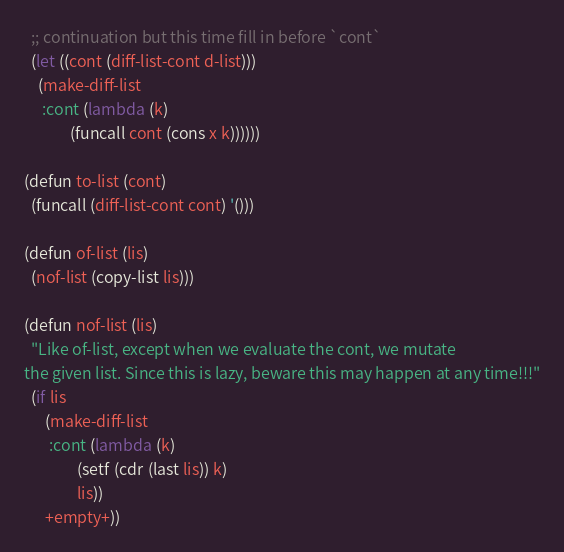Convert code to text. <code><loc_0><loc_0><loc_500><loc_500><_Lisp_>  ;; continuation but this time fill in before `cont`
  (let ((cont (diff-list-cont d-list)))
    (make-diff-list
     :cont (lambda (k)
             (funcall cont (cons x k))))))

(defun to-list (cont)
  (funcall (diff-list-cont cont) '()))

(defun of-list (lis)
  (nof-list (copy-list lis)))

(defun nof-list (lis)
  "Like of-list, except when we evaluate the cont, we mutate
the given list. Since this is lazy, beware this may happen at any time!!!"
  (if lis
      (make-diff-list
       :cont (lambda (k)
               (setf (cdr (last lis)) k)
               lis))
      +empty+))
</code> 